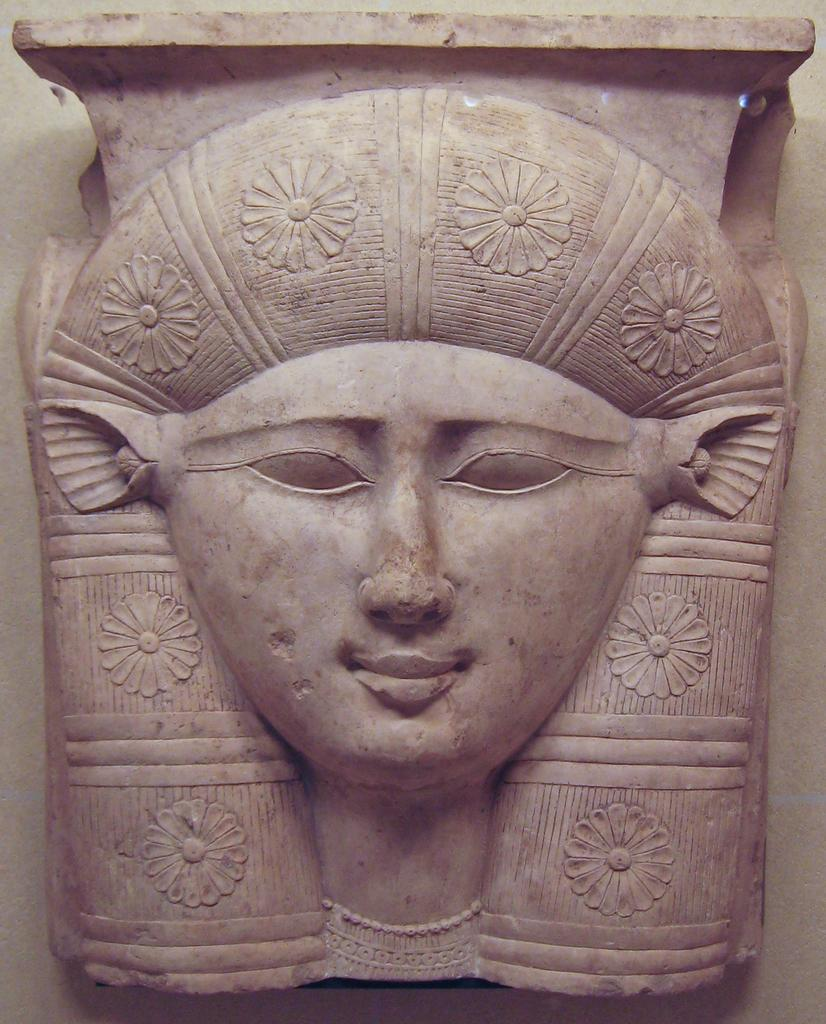What is the main subject of the image? There is a sculpture in the image. What color is the sculpture? The sculpture is pink in color. What is depicted on the sculpture? The sculpture has a person's face on it. Are there any additional elements on the sculpture? Yes, there are flowers on the sculpture. What is the sculpture placed on? The sculpture is on a cream-colored surface. What type of insurance policy is being advertised on the sculpture? There is no insurance policy or advertisement present on the sculpture; it is a sculpture with a person's face and flowers. 